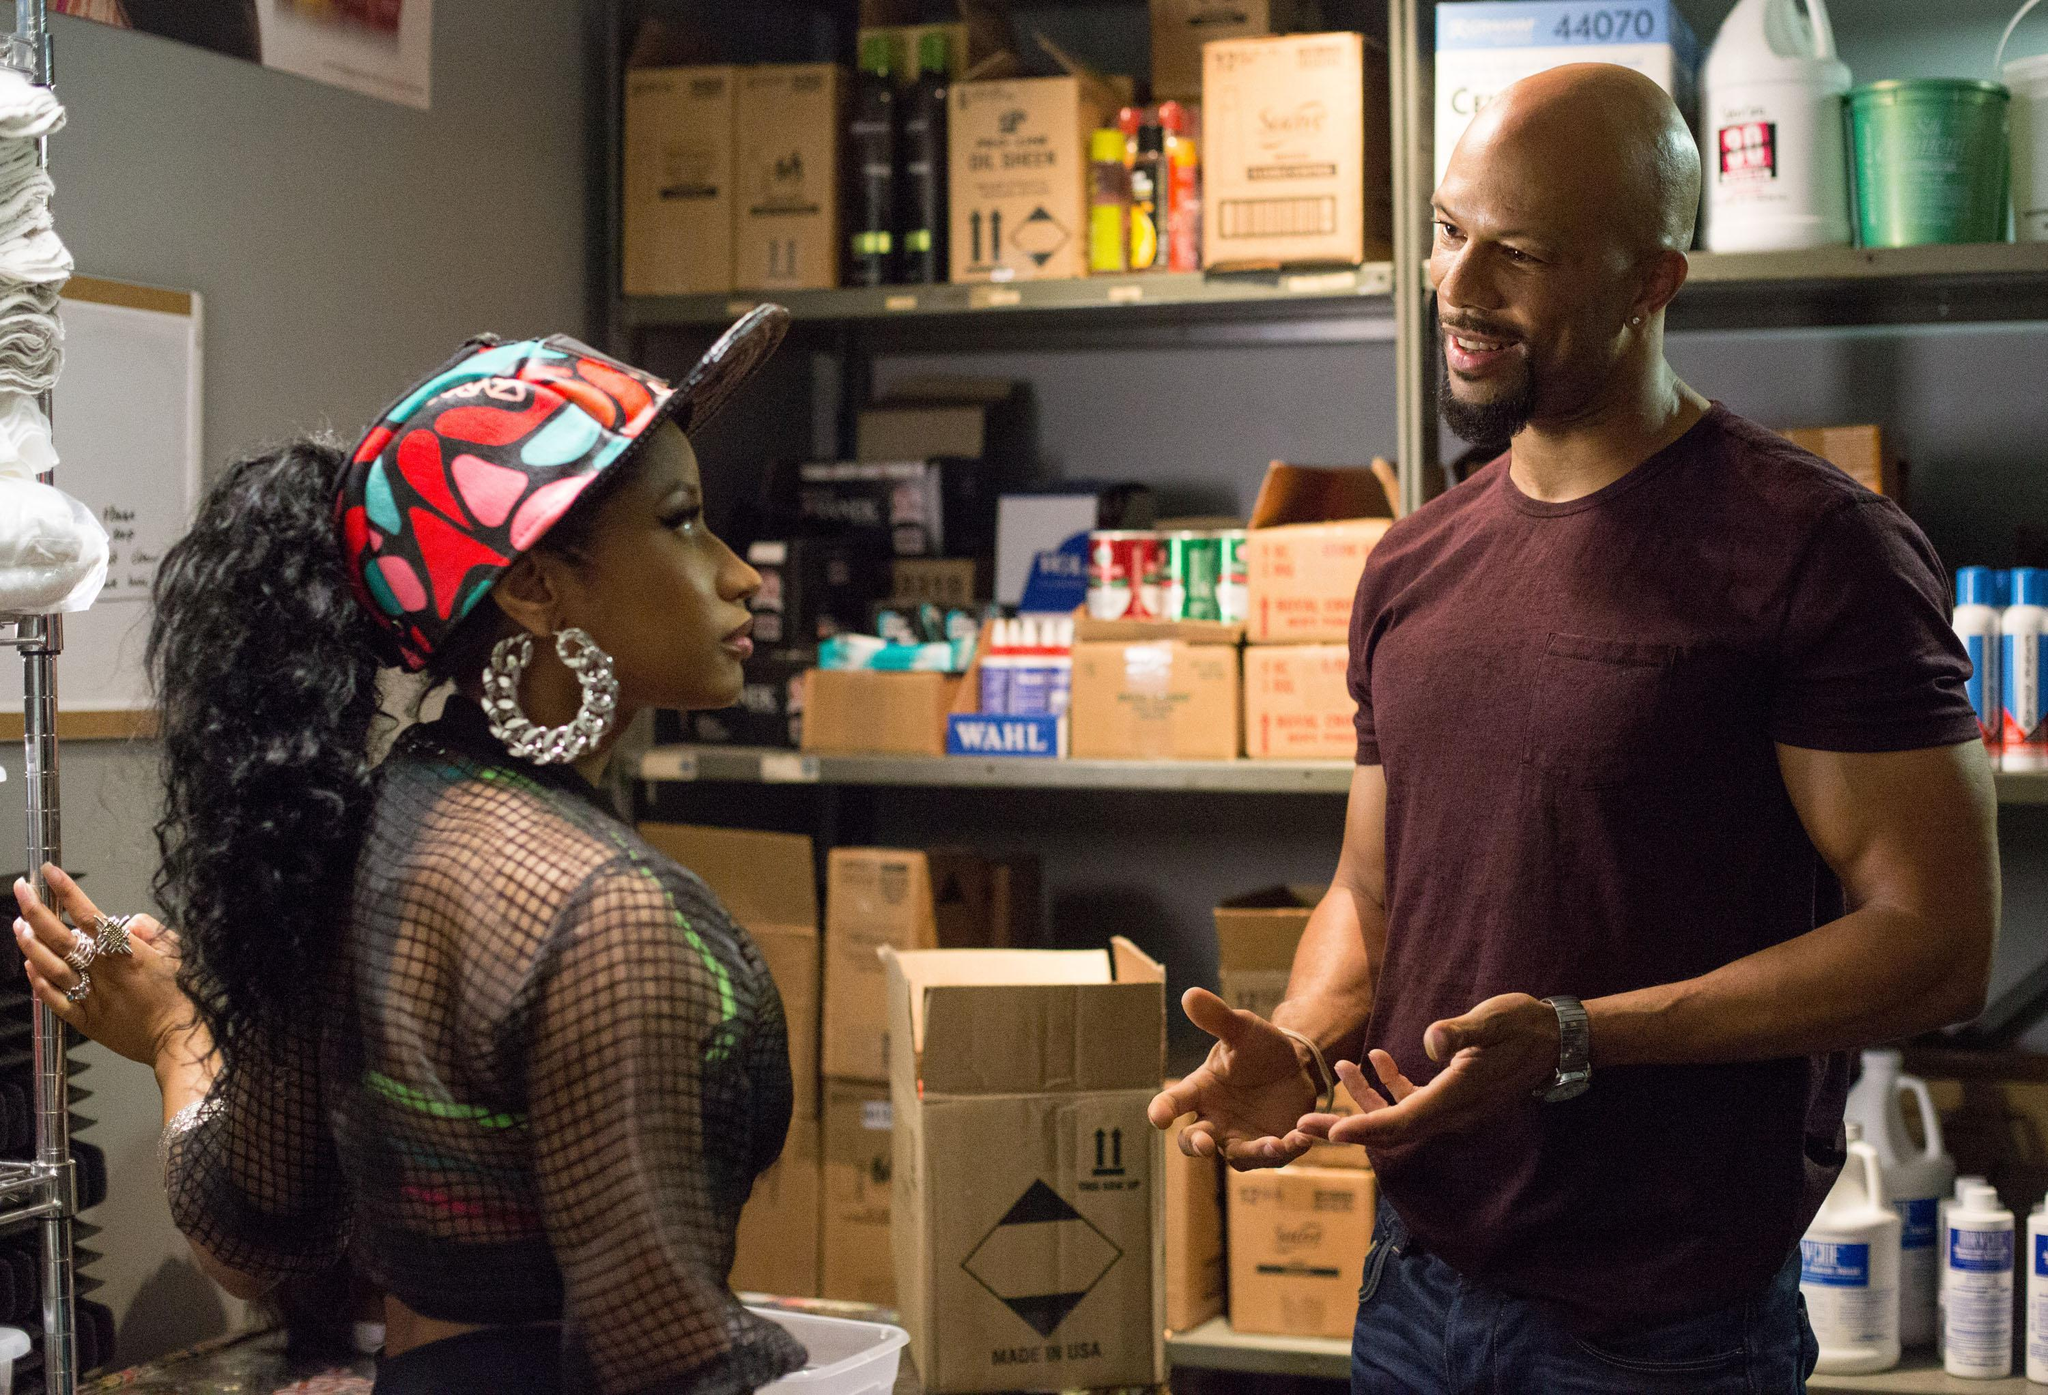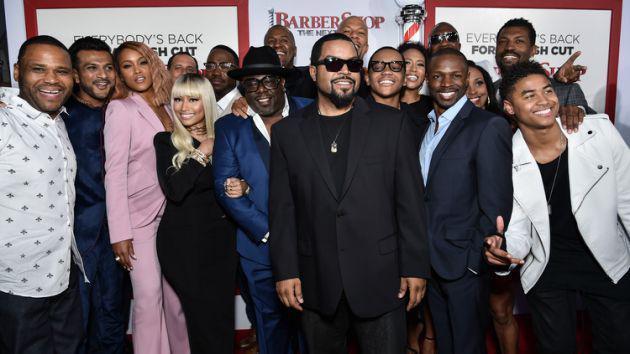The first image is the image on the left, the second image is the image on the right. Evaluate the accuracy of this statement regarding the images: "An image includes a black man with grizzled gray hair and beard, wearing a white top and khaki pants, and sitting in a barber chair.". Is it true? Answer yes or no. No. The first image is the image on the left, the second image is the image on the right. Assess this claim about the two images: "The woman in the image on the right is standing in front of a brick wall.". Correct or not? Answer yes or no. No. 